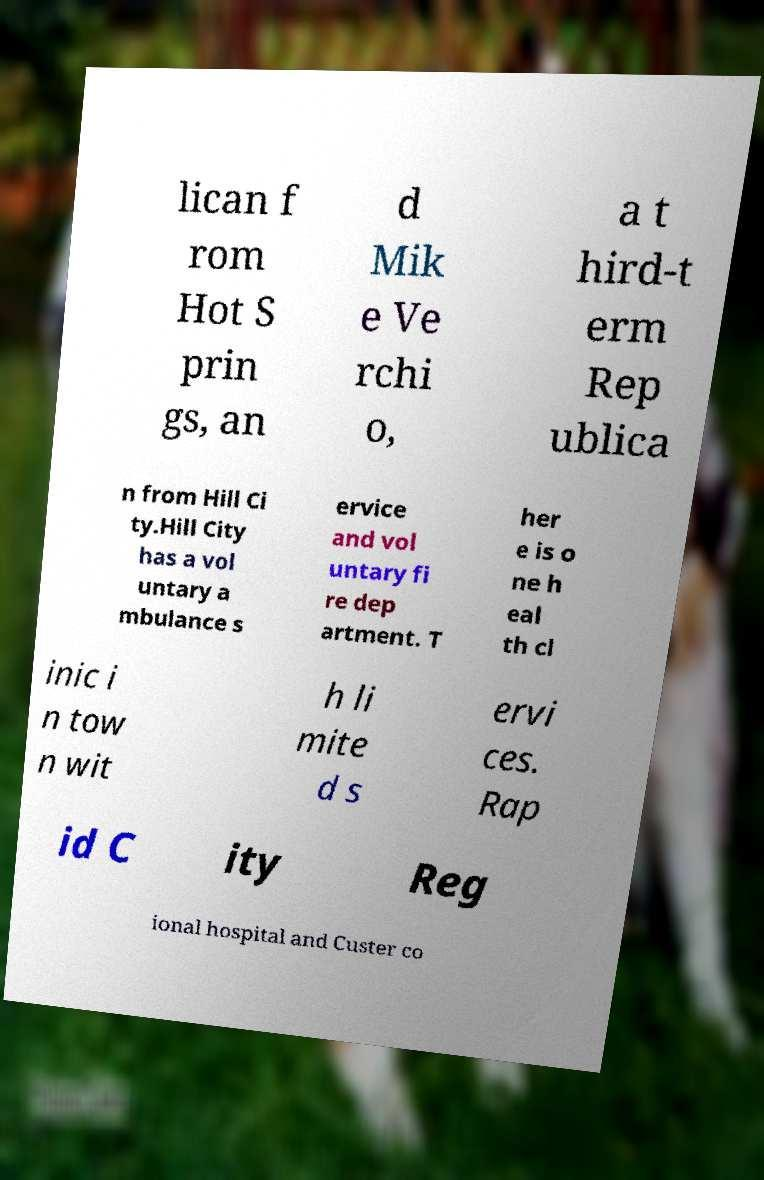Can you accurately transcribe the text from the provided image for me? lican f rom Hot S prin gs, an d Mik e Ve rchi o, a t hird-t erm Rep ublica n from Hill Ci ty.Hill City has a vol untary a mbulance s ervice and vol untary fi re dep artment. T her e is o ne h eal th cl inic i n tow n wit h li mite d s ervi ces. Rap id C ity Reg ional hospital and Custer co 